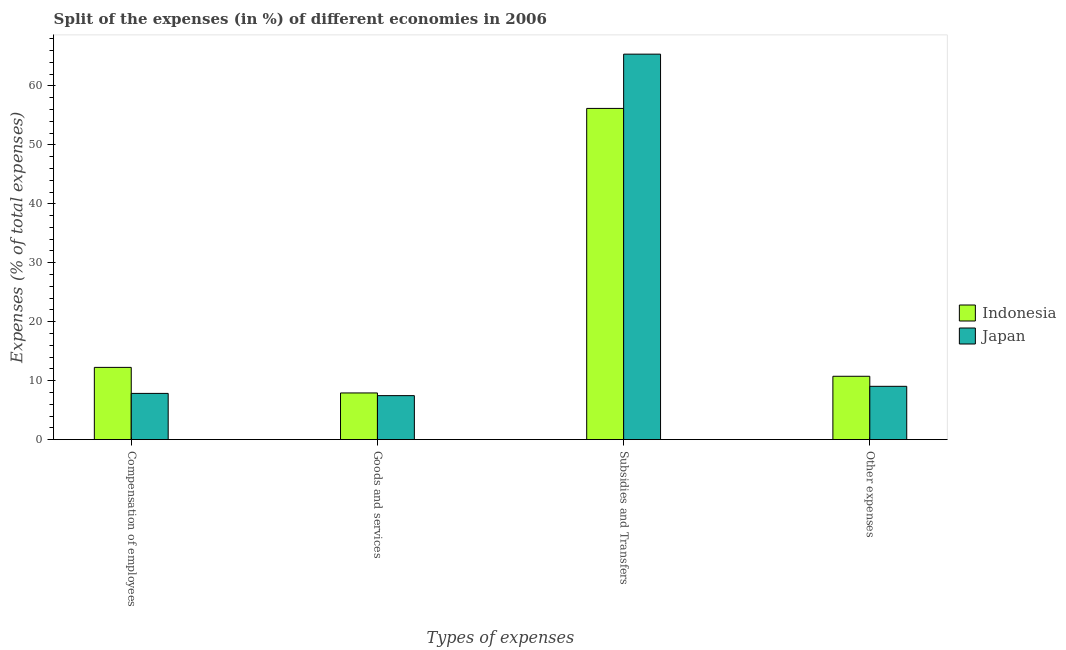Are the number of bars on each tick of the X-axis equal?
Your answer should be very brief. Yes. What is the label of the 3rd group of bars from the left?
Give a very brief answer. Subsidies and Transfers. What is the percentage of amount spent on compensation of employees in Indonesia?
Ensure brevity in your answer.  12.25. Across all countries, what is the maximum percentage of amount spent on compensation of employees?
Your answer should be very brief. 12.25. Across all countries, what is the minimum percentage of amount spent on goods and services?
Offer a terse response. 7.46. What is the total percentage of amount spent on other expenses in the graph?
Your answer should be very brief. 19.79. What is the difference between the percentage of amount spent on subsidies in Japan and that in Indonesia?
Provide a succinct answer. 9.21. What is the difference between the percentage of amount spent on compensation of employees in Indonesia and the percentage of amount spent on other expenses in Japan?
Make the answer very short. 3.21. What is the average percentage of amount spent on compensation of employees per country?
Provide a short and direct response. 10.05. What is the difference between the percentage of amount spent on compensation of employees and percentage of amount spent on goods and services in Japan?
Provide a short and direct response. 0.38. In how many countries, is the percentage of amount spent on compensation of employees greater than 36 %?
Offer a terse response. 0. What is the ratio of the percentage of amount spent on other expenses in Japan to that in Indonesia?
Keep it short and to the point. 0.84. Is the percentage of amount spent on subsidies in Indonesia less than that in Japan?
Your answer should be compact. Yes. Is the difference between the percentage of amount spent on subsidies in Japan and Indonesia greater than the difference between the percentage of amount spent on compensation of employees in Japan and Indonesia?
Keep it short and to the point. Yes. What is the difference between the highest and the second highest percentage of amount spent on goods and services?
Keep it short and to the point. 0.46. What is the difference between the highest and the lowest percentage of amount spent on other expenses?
Your answer should be compact. 1.7. Is it the case that in every country, the sum of the percentage of amount spent on subsidies and percentage of amount spent on other expenses is greater than the sum of percentage of amount spent on goods and services and percentage of amount spent on compensation of employees?
Your response must be concise. Yes. What does the 1st bar from the left in Subsidies and Transfers represents?
Keep it short and to the point. Indonesia. Are all the bars in the graph horizontal?
Offer a terse response. No. How many countries are there in the graph?
Provide a succinct answer. 2. How many legend labels are there?
Your response must be concise. 2. What is the title of the graph?
Ensure brevity in your answer.  Split of the expenses (in %) of different economies in 2006. Does "Syrian Arab Republic" appear as one of the legend labels in the graph?
Provide a short and direct response. No. What is the label or title of the X-axis?
Keep it short and to the point. Types of expenses. What is the label or title of the Y-axis?
Keep it short and to the point. Expenses (% of total expenses). What is the Expenses (% of total expenses) in Indonesia in Compensation of employees?
Provide a succinct answer. 12.25. What is the Expenses (% of total expenses) in Japan in Compensation of employees?
Your response must be concise. 7.84. What is the Expenses (% of total expenses) in Indonesia in Goods and services?
Provide a short and direct response. 7.92. What is the Expenses (% of total expenses) in Japan in Goods and services?
Keep it short and to the point. 7.46. What is the Expenses (% of total expenses) in Indonesia in Subsidies and Transfers?
Offer a very short reply. 56.19. What is the Expenses (% of total expenses) in Japan in Subsidies and Transfers?
Offer a terse response. 65.39. What is the Expenses (% of total expenses) in Indonesia in Other expenses?
Your response must be concise. 10.74. What is the Expenses (% of total expenses) of Japan in Other expenses?
Make the answer very short. 9.04. Across all Types of expenses, what is the maximum Expenses (% of total expenses) in Indonesia?
Keep it short and to the point. 56.19. Across all Types of expenses, what is the maximum Expenses (% of total expenses) of Japan?
Offer a very short reply. 65.39. Across all Types of expenses, what is the minimum Expenses (% of total expenses) in Indonesia?
Provide a succinct answer. 7.92. Across all Types of expenses, what is the minimum Expenses (% of total expenses) in Japan?
Make the answer very short. 7.46. What is the total Expenses (% of total expenses) of Indonesia in the graph?
Keep it short and to the point. 87.1. What is the total Expenses (% of total expenses) in Japan in the graph?
Your answer should be very brief. 89.73. What is the difference between the Expenses (% of total expenses) of Indonesia in Compensation of employees and that in Goods and services?
Give a very brief answer. 4.33. What is the difference between the Expenses (% of total expenses) in Japan in Compensation of employees and that in Goods and services?
Provide a short and direct response. 0.38. What is the difference between the Expenses (% of total expenses) in Indonesia in Compensation of employees and that in Subsidies and Transfers?
Make the answer very short. -43.94. What is the difference between the Expenses (% of total expenses) in Japan in Compensation of employees and that in Subsidies and Transfers?
Offer a very short reply. -57.56. What is the difference between the Expenses (% of total expenses) in Indonesia in Compensation of employees and that in Other expenses?
Your response must be concise. 1.51. What is the difference between the Expenses (% of total expenses) of Japan in Compensation of employees and that in Other expenses?
Ensure brevity in your answer.  -1.2. What is the difference between the Expenses (% of total expenses) of Indonesia in Goods and services and that in Subsidies and Transfers?
Your response must be concise. -48.27. What is the difference between the Expenses (% of total expenses) of Japan in Goods and services and that in Subsidies and Transfers?
Make the answer very short. -57.94. What is the difference between the Expenses (% of total expenses) in Indonesia in Goods and services and that in Other expenses?
Provide a succinct answer. -2.83. What is the difference between the Expenses (% of total expenses) of Japan in Goods and services and that in Other expenses?
Offer a very short reply. -1.58. What is the difference between the Expenses (% of total expenses) of Indonesia in Subsidies and Transfers and that in Other expenses?
Provide a succinct answer. 45.44. What is the difference between the Expenses (% of total expenses) in Japan in Subsidies and Transfers and that in Other expenses?
Your answer should be compact. 56.35. What is the difference between the Expenses (% of total expenses) of Indonesia in Compensation of employees and the Expenses (% of total expenses) of Japan in Goods and services?
Your answer should be compact. 4.79. What is the difference between the Expenses (% of total expenses) in Indonesia in Compensation of employees and the Expenses (% of total expenses) in Japan in Subsidies and Transfers?
Your response must be concise. -53.14. What is the difference between the Expenses (% of total expenses) of Indonesia in Compensation of employees and the Expenses (% of total expenses) of Japan in Other expenses?
Provide a short and direct response. 3.21. What is the difference between the Expenses (% of total expenses) in Indonesia in Goods and services and the Expenses (% of total expenses) in Japan in Subsidies and Transfers?
Keep it short and to the point. -57.48. What is the difference between the Expenses (% of total expenses) of Indonesia in Goods and services and the Expenses (% of total expenses) of Japan in Other expenses?
Provide a succinct answer. -1.12. What is the difference between the Expenses (% of total expenses) of Indonesia in Subsidies and Transfers and the Expenses (% of total expenses) of Japan in Other expenses?
Keep it short and to the point. 47.15. What is the average Expenses (% of total expenses) of Indonesia per Types of expenses?
Your answer should be compact. 21.78. What is the average Expenses (% of total expenses) of Japan per Types of expenses?
Your answer should be very brief. 22.43. What is the difference between the Expenses (% of total expenses) of Indonesia and Expenses (% of total expenses) of Japan in Compensation of employees?
Your answer should be very brief. 4.41. What is the difference between the Expenses (% of total expenses) in Indonesia and Expenses (% of total expenses) in Japan in Goods and services?
Provide a succinct answer. 0.46. What is the difference between the Expenses (% of total expenses) in Indonesia and Expenses (% of total expenses) in Japan in Subsidies and Transfers?
Make the answer very short. -9.21. What is the difference between the Expenses (% of total expenses) in Indonesia and Expenses (% of total expenses) in Japan in Other expenses?
Your answer should be compact. 1.7. What is the ratio of the Expenses (% of total expenses) of Indonesia in Compensation of employees to that in Goods and services?
Provide a succinct answer. 1.55. What is the ratio of the Expenses (% of total expenses) of Japan in Compensation of employees to that in Goods and services?
Your answer should be very brief. 1.05. What is the ratio of the Expenses (% of total expenses) of Indonesia in Compensation of employees to that in Subsidies and Transfers?
Offer a very short reply. 0.22. What is the ratio of the Expenses (% of total expenses) in Japan in Compensation of employees to that in Subsidies and Transfers?
Provide a succinct answer. 0.12. What is the ratio of the Expenses (% of total expenses) in Indonesia in Compensation of employees to that in Other expenses?
Ensure brevity in your answer.  1.14. What is the ratio of the Expenses (% of total expenses) in Japan in Compensation of employees to that in Other expenses?
Keep it short and to the point. 0.87. What is the ratio of the Expenses (% of total expenses) of Indonesia in Goods and services to that in Subsidies and Transfers?
Your answer should be compact. 0.14. What is the ratio of the Expenses (% of total expenses) of Japan in Goods and services to that in Subsidies and Transfers?
Offer a very short reply. 0.11. What is the ratio of the Expenses (% of total expenses) in Indonesia in Goods and services to that in Other expenses?
Provide a short and direct response. 0.74. What is the ratio of the Expenses (% of total expenses) of Japan in Goods and services to that in Other expenses?
Offer a terse response. 0.82. What is the ratio of the Expenses (% of total expenses) of Indonesia in Subsidies and Transfers to that in Other expenses?
Give a very brief answer. 5.23. What is the ratio of the Expenses (% of total expenses) of Japan in Subsidies and Transfers to that in Other expenses?
Provide a succinct answer. 7.23. What is the difference between the highest and the second highest Expenses (% of total expenses) of Indonesia?
Offer a very short reply. 43.94. What is the difference between the highest and the second highest Expenses (% of total expenses) in Japan?
Keep it short and to the point. 56.35. What is the difference between the highest and the lowest Expenses (% of total expenses) of Indonesia?
Your answer should be compact. 48.27. What is the difference between the highest and the lowest Expenses (% of total expenses) in Japan?
Your answer should be very brief. 57.94. 